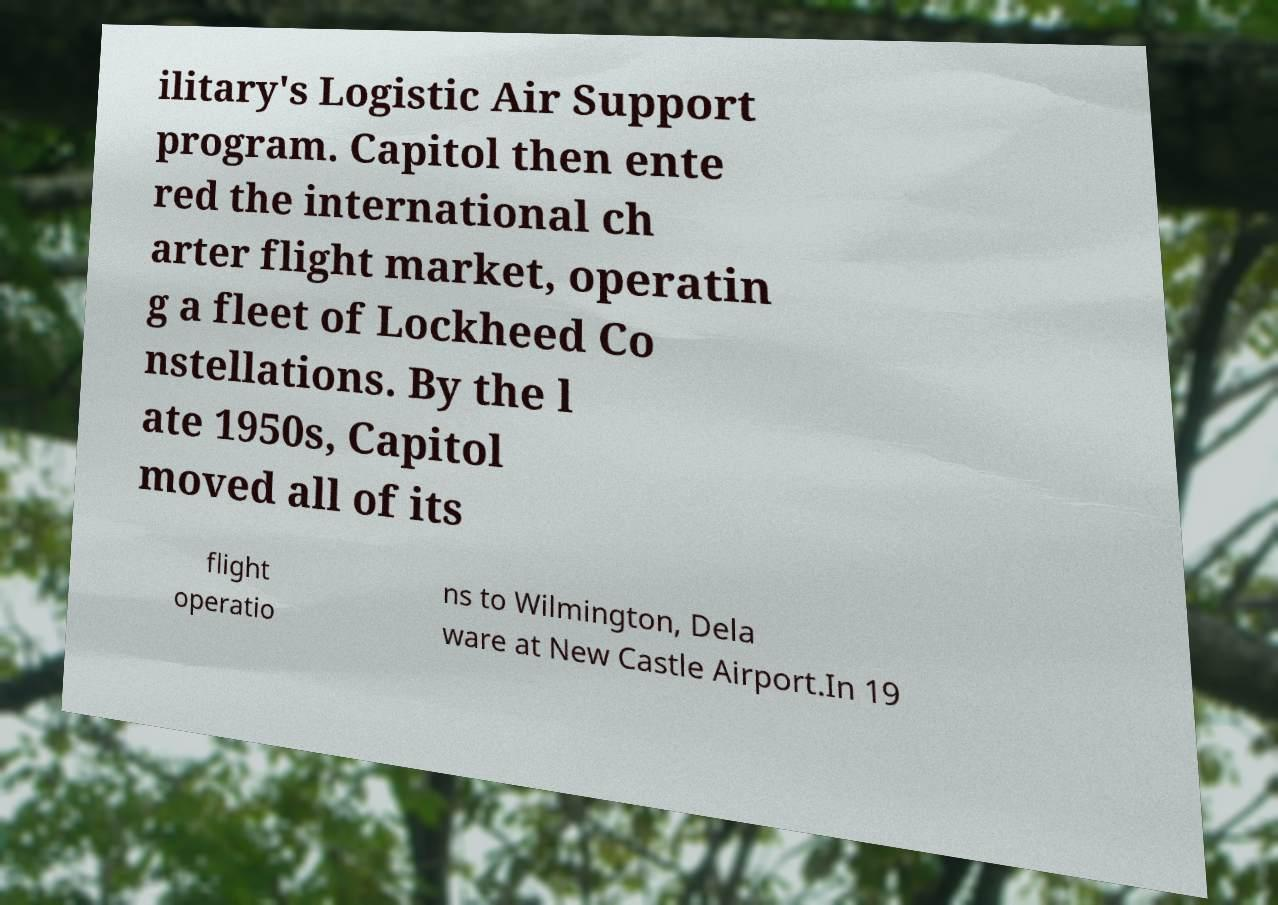Can you accurately transcribe the text from the provided image for me? ilitary's Logistic Air Support program. Capitol then ente red the international ch arter flight market, operatin g a fleet of Lockheed Co nstellations. By the l ate 1950s, Capitol moved all of its flight operatio ns to Wilmington, Dela ware at New Castle Airport.In 19 